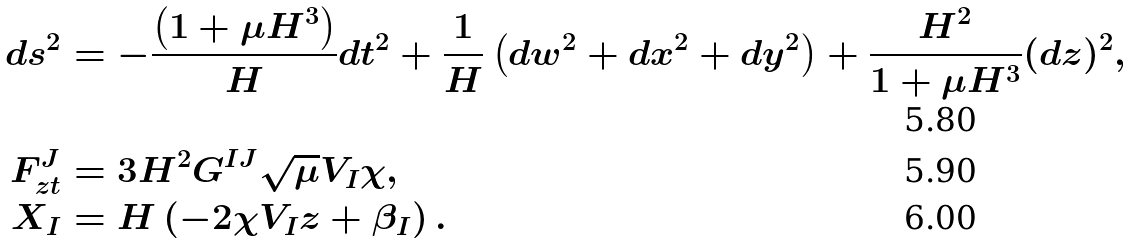Convert formula to latex. <formula><loc_0><loc_0><loc_500><loc_500>d s ^ { 2 } & = - \frac { \left ( 1 + \mu H ^ { 3 } \right ) } { H } d t ^ { 2 } + \frac { 1 } { H } \left ( d w ^ { 2 } + d x ^ { 2 } + d y ^ { 2 } \right ) + \frac { H ^ { 2 } } { 1 + \mu H ^ { 3 } } ( d z ) ^ { 2 } , \\ F _ { z t } ^ { J } & = 3 H ^ { 2 } G ^ { I J } \sqrt { \mu } V _ { I } \chi , \\ X _ { I } & = H \left ( - 2 \chi V _ { I } z + \beta _ { I } \right ) .</formula> 